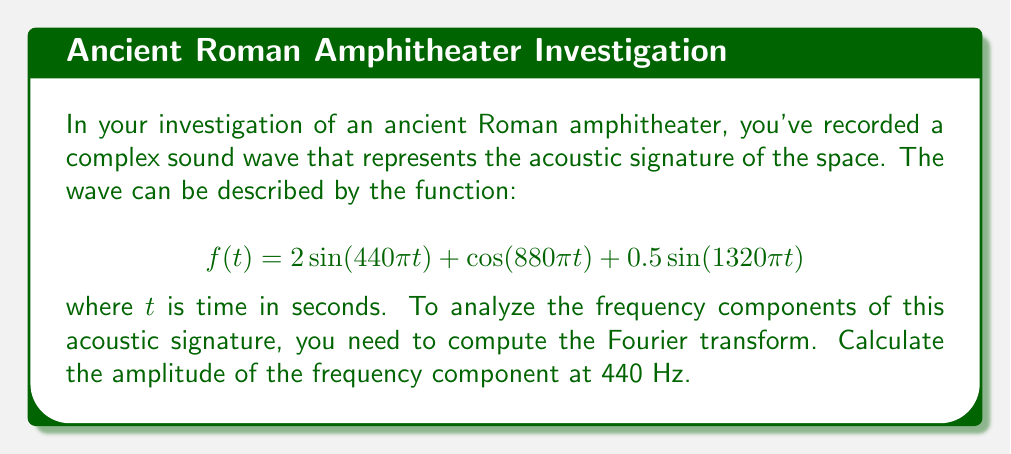What is the answer to this math problem? To solve this problem, we'll follow these steps:

1) The Fourier transform of a sinusoidal function is given by:

   $$\mathcal{F}\{A\sin(2\pi ft)\} = \frac{iA}{2}[\delta(F-f) - \delta(F+f)]$$
   $$\mathcal{F}\{A\cos(2\pi ft)\} = \frac{A}{2}[\delta(F-f) + \delta(F+f)]$$

   where $\delta$ is the Dirac delta function, $f$ is the frequency, and $F$ is the frequency variable in the Fourier domain.

2) Our function $f(t)$ consists of three terms:
   
   $$f(t) = 2\sin(440\pi t) + \cos(880\pi t) + 0.5\sin(1320\pi t)$$

3) We need to transform each term:

   For $2\sin(440\pi t)$: $f = 220$ Hz, $A = 2$
   $$\mathcal{F}\{2\sin(440\pi t)\} = i[\delta(F-220) - \delta(F+220)]$$

   For $\cos(880\pi t)$: $f = 440$ Hz, $A = 1$
   $$\mathcal{F}\{\cos(880\pi t)\} = 0.5[\delta(F-440) + \delta(F+440)]$$

   For $0.5\sin(1320\pi t)$: $f = 660$ Hz, $A = 0.5$
   $$\mathcal{F}\{0.5\sin(1320\pi t)\} = 0.25i[\delta(F-660) - \delta(F+660)]$$

4) The Fourier transform of $f(t)$ is the sum of these components:

   $$\mathcal{F}\{f(t)\} = i[\delta(F-220) - \delta(F+220)] + 0.5[\delta(F-440) + \delta(F+440)] + 0.25i[\delta(F-660) - \delta(F+660)]$$

5) The amplitude of the frequency component at 440 Hz is given by the coefficient of $\delta(F-440)$, which is 0.5.
Answer: The amplitude of the frequency component at 440 Hz is 0.5. 